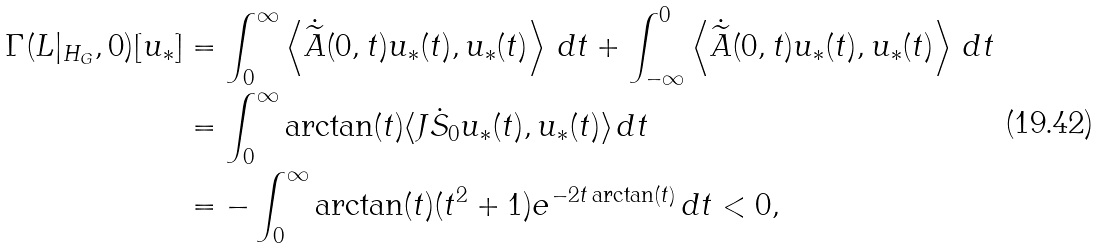Convert formula to latex. <formula><loc_0><loc_0><loc_500><loc_500>\Gamma ( L | _ { H _ { G } } , 0 ) [ u _ { \ast } ] & = \int ^ { \infty } _ { 0 } { \left \langle \dot { \widetilde { A } } ( 0 , t ) u _ { \ast } ( t ) , u _ { \ast } ( t ) \right \rangle \, d t } + \int ^ { 0 } _ { - \infty } { \left \langle \dot { \widetilde { A } } ( 0 , t ) u _ { \ast } ( t ) , u _ { \ast } ( t ) \right \rangle \, d t } \\ & = \int ^ { \infty } _ { 0 } { \arctan ( t ) \langle J \dot { S } _ { 0 } u _ { \ast } ( t ) , u _ { \ast } ( t ) \rangle \, d t } \\ & = - \int ^ { \infty } _ { 0 } { \arctan ( t ) ( t ^ { 2 } + 1 ) e ^ { - 2 t \arctan ( t ) } \, d t } < 0 ,</formula> 